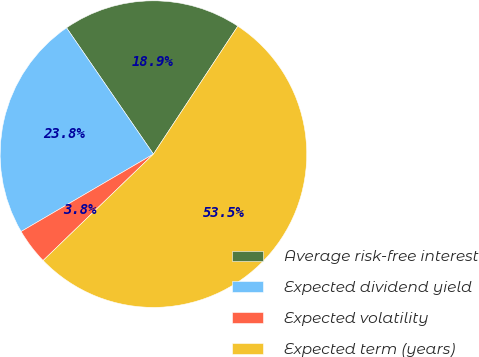<chart> <loc_0><loc_0><loc_500><loc_500><pie_chart><fcel>Average risk-free interest<fcel>Expected dividend yield<fcel>Expected volatility<fcel>Expected term (years)<nl><fcel>18.87%<fcel>23.83%<fcel>3.79%<fcel>53.5%<nl></chart> 